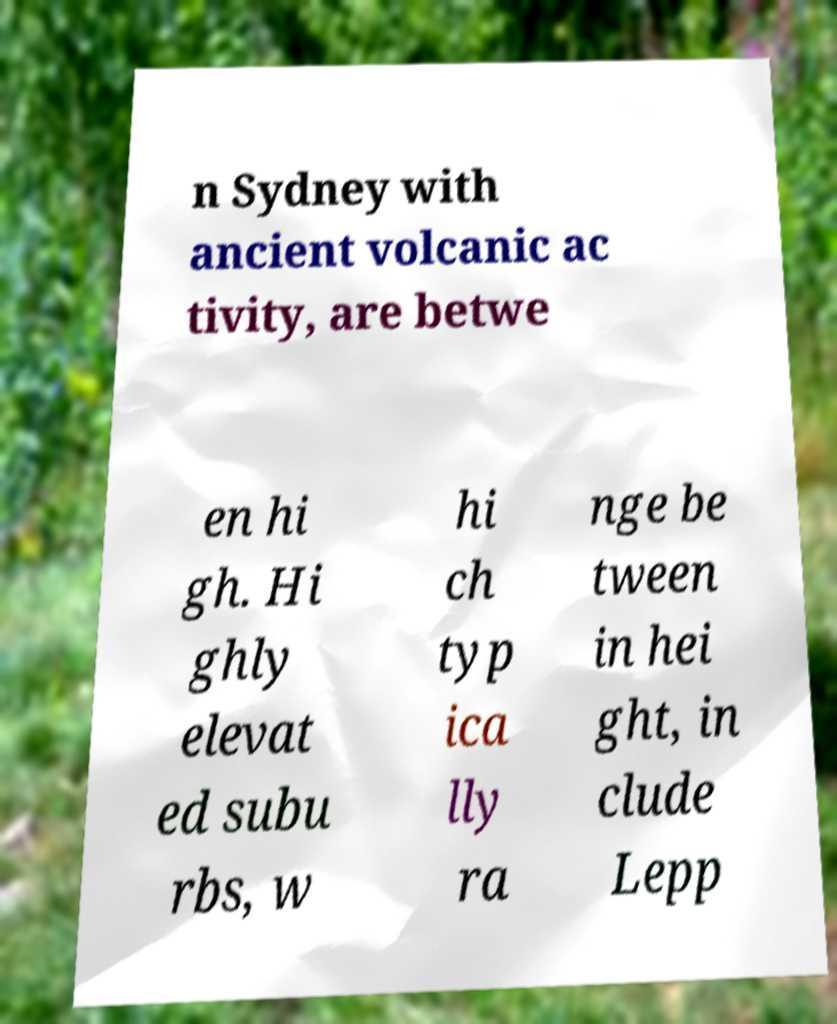Can you read and provide the text displayed in the image?This photo seems to have some interesting text. Can you extract and type it out for me? n Sydney with ancient volcanic ac tivity, are betwe en hi gh. Hi ghly elevat ed subu rbs, w hi ch typ ica lly ra nge be tween in hei ght, in clude Lepp 